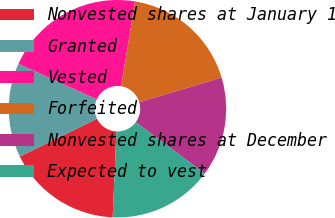Convert chart. <chart><loc_0><loc_0><loc_500><loc_500><pie_chart><fcel>Nonvested shares at January 1<fcel>Granted<fcel>Vested<fcel>Forfeited<fcel>Nonvested shares at December<fcel>Expected to vest<nl><fcel>17.05%<fcel>14.02%<fcel>20.81%<fcel>17.8%<fcel>14.78%<fcel>15.53%<nl></chart> 